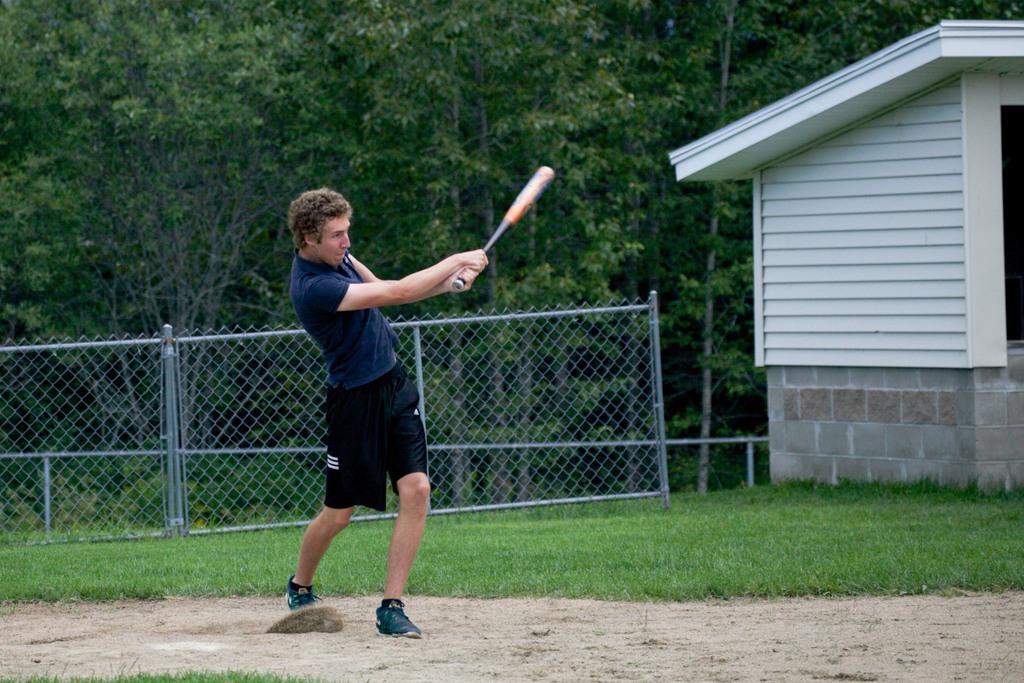What is the person in the image doing? The person is standing on the land and holding a waffle. What can be seen in the background of the image? There is a fence, grass, a house with a roof, and trees visible in the image. What type of structure is present in the image? There is a house with a roof in the image. What type of instrument is the person playing in the image? There is no instrument present in the image; the person is holding a waffle. How many hens can be seen in the image? There are no hens present in the image. 